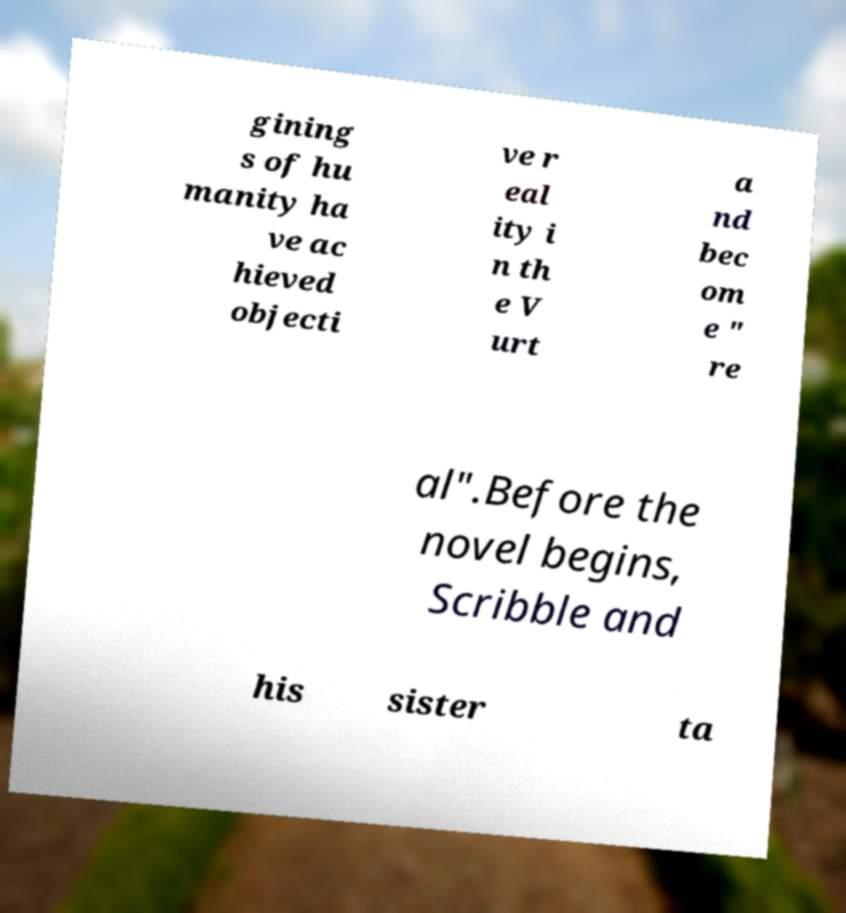Please read and relay the text visible in this image. What does it say? gining s of hu manity ha ve ac hieved objecti ve r eal ity i n th e V urt a nd bec om e " re al".Before the novel begins, Scribble and his sister ta 